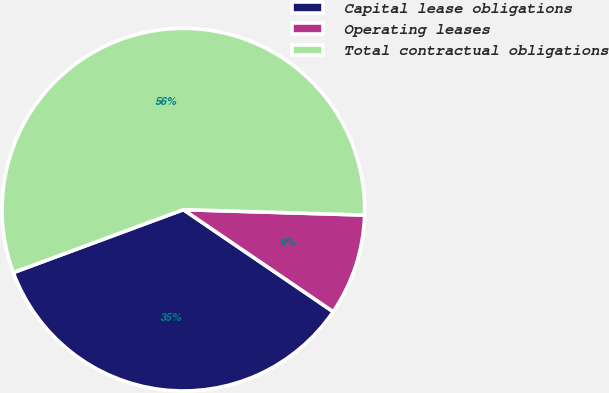Convert chart. <chart><loc_0><loc_0><loc_500><loc_500><pie_chart><fcel>Capital lease obligations<fcel>Operating leases<fcel>Total contractual obligations<nl><fcel>34.84%<fcel>9.04%<fcel>56.12%<nl></chart> 